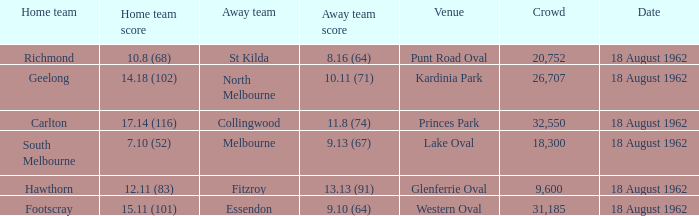Which domestic team managed to score 1 Richmond. 